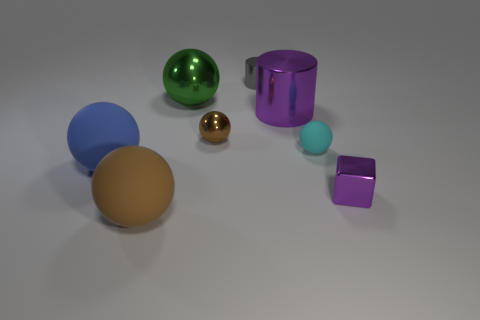Subtract all tiny spheres. How many spheres are left? 3 Subtract 2 balls. How many balls are left? 3 Subtract all cyan balls. How many balls are left? 4 Add 1 green metal things. How many objects exist? 9 Subtract all red balls. Subtract all blue cylinders. How many balls are left? 5 Subtract all balls. How many objects are left? 3 Add 4 large cylinders. How many large cylinders are left? 5 Add 1 blue spheres. How many blue spheres exist? 2 Subtract 0 blue cubes. How many objects are left? 8 Subtract all shiny cubes. Subtract all blue metallic cylinders. How many objects are left? 7 